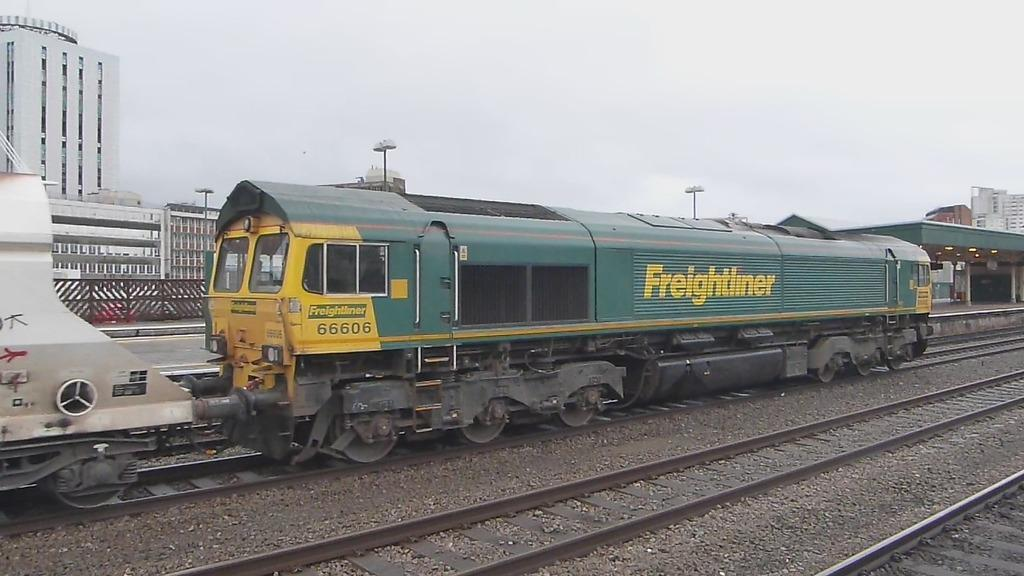What can be seen running along the ground in the image? There are railway tracks in the image, and a rail engine is present on the tracks. What type of vehicle is on the railway tracks? A rail engine is present on the tracks. What can be seen in the distance in the image? There are buildings and poles in the background of the image. How would you describe the weather in the image? The sky is cloudy in the image. How much sugar is being used to copy the stick in the image? There is no sugar, copying, or stick present in the image. 